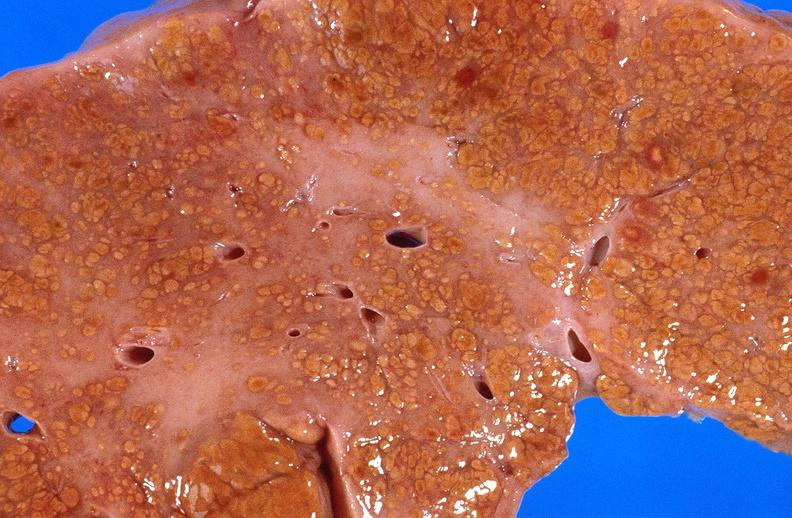what does this image show?
Answer the question using a single word or phrase. Cirrhosis 